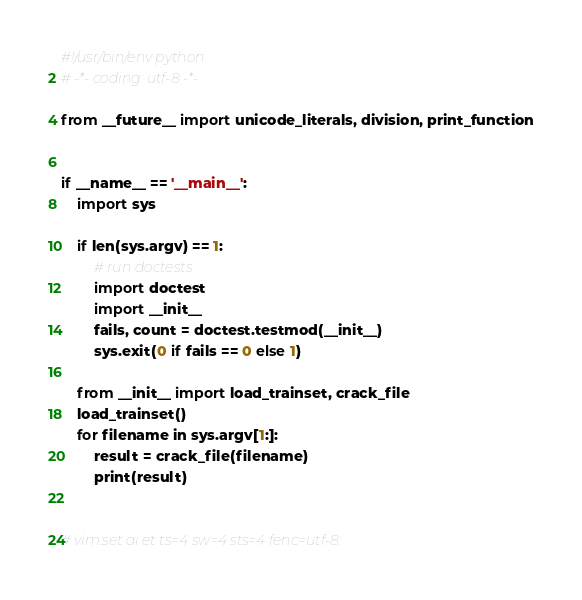Convert code to text. <code><loc_0><loc_0><loc_500><loc_500><_Python_>#!/usr/bin/env python
# -*- coding: utf-8 -*-

from __future__ import unicode_literals, division, print_function


if __name__ == '__main__':
    import sys

    if len(sys.argv) == 1:
        # run doctests
        import doctest
        import __init__
        fails, count = doctest.testmod(__init__)
        sys.exit(0 if fails == 0 else 1)

    from __init__ import load_trainset, crack_file
    load_trainset()
    for filename in sys.argv[1:]:
        result = crack_file(filename)
        print(result)


# vim:set ai et ts=4 sw=4 sts=4 fenc=utf-8:
</code> 